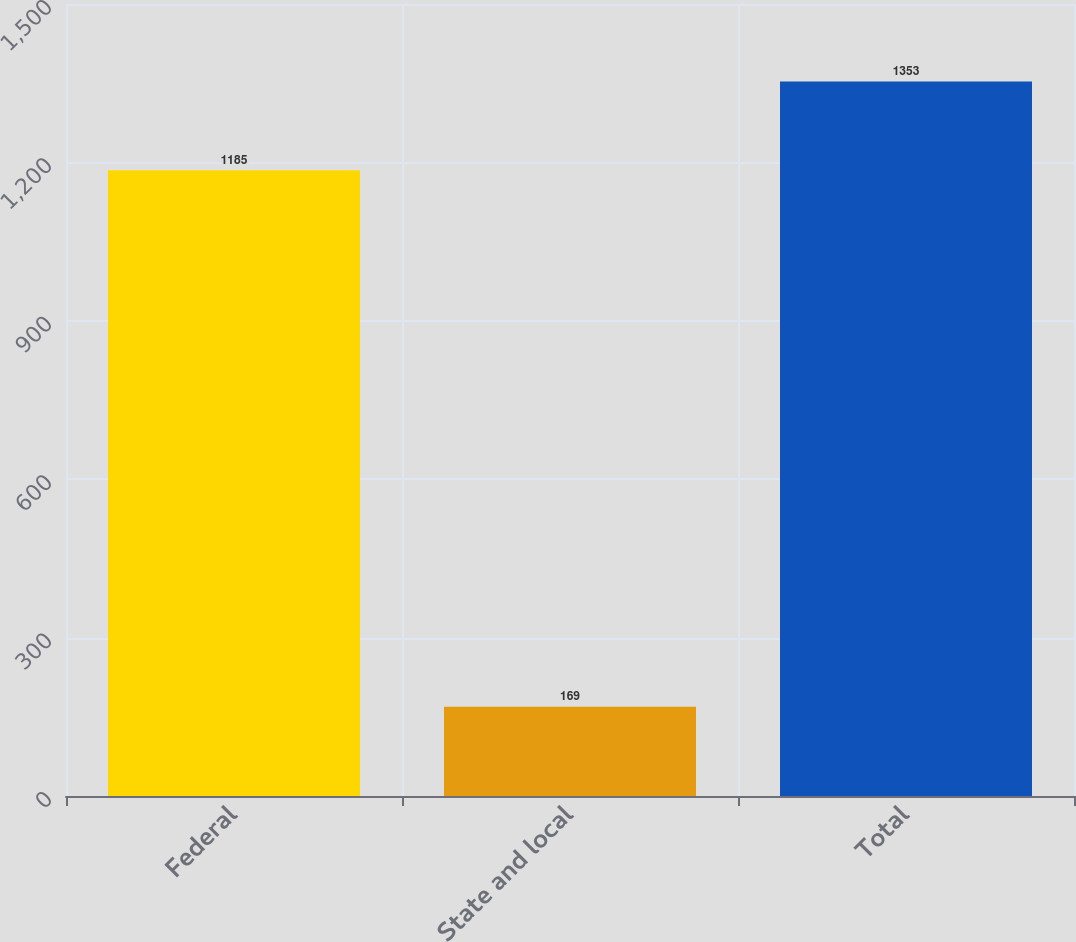<chart> <loc_0><loc_0><loc_500><loc_500><bar_chart><fcel>Federal<fcel>State and local<fcel>Total<nl><fcel>1185<fcel>169<fcel>1353<nl></chart> 